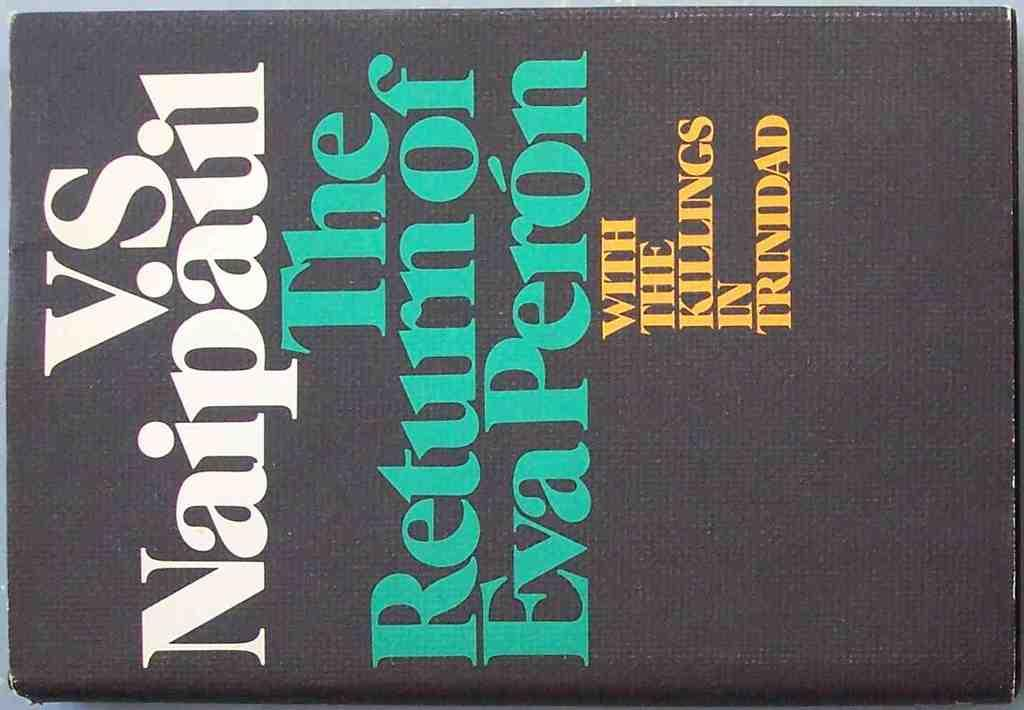<image>
Create a compact narrative representing the image presented. An older and worn book proclaims the return of Eva Peron 